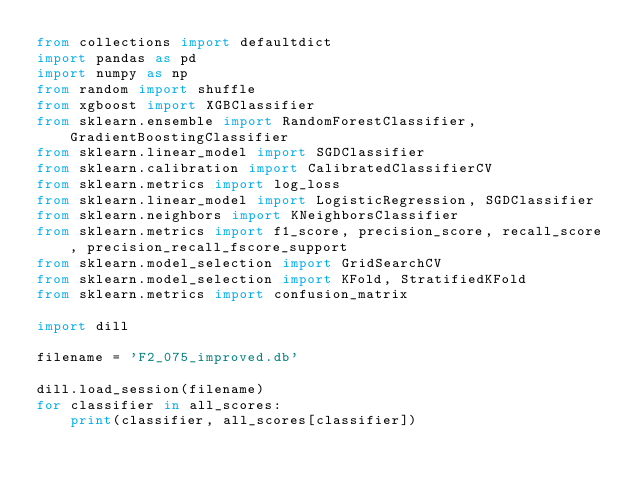<code> <loc_0><loc_0><loc_500><loc_500><_Python_>from collections import defaultdict
import pandas as pd
import numpy as np
from random import shuffle
from xgboost import XGBClassifier
from sklearn.ensemble import RandomForestClassifier, GradientBoostingClassifier
from sklearn.linear_model import SGDClassifier
from sklearn.calibration import CalibratedClassifierCV
from sklearn.metrics import log_loss
from sklearn.linear_model import LogisticRegression, SGDClassifier
from sklearn.neighbors import KNeighborsClassifier
from sklearn.metrics import f1_score, precision_score, recall_score, precision_recall_fscore_support
from sklearn.model_selection import GridSearchCV
from sklearn.model_selection import KFold, StratifiedKFold
from sklearn.metrics import confusion_matrix

import dill

filename = 'F2_075_improved.db'

dill.load_session(filename)
for classifier in all_scores:
    print(classifier, all_scores[classifier])
</code> 